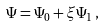<formula> <loc_0><loc_0><loc_500><loc_500>\Psi = \Psi _ { 0 } + \xi \Psi _ { 1 } \, ,</formula> 